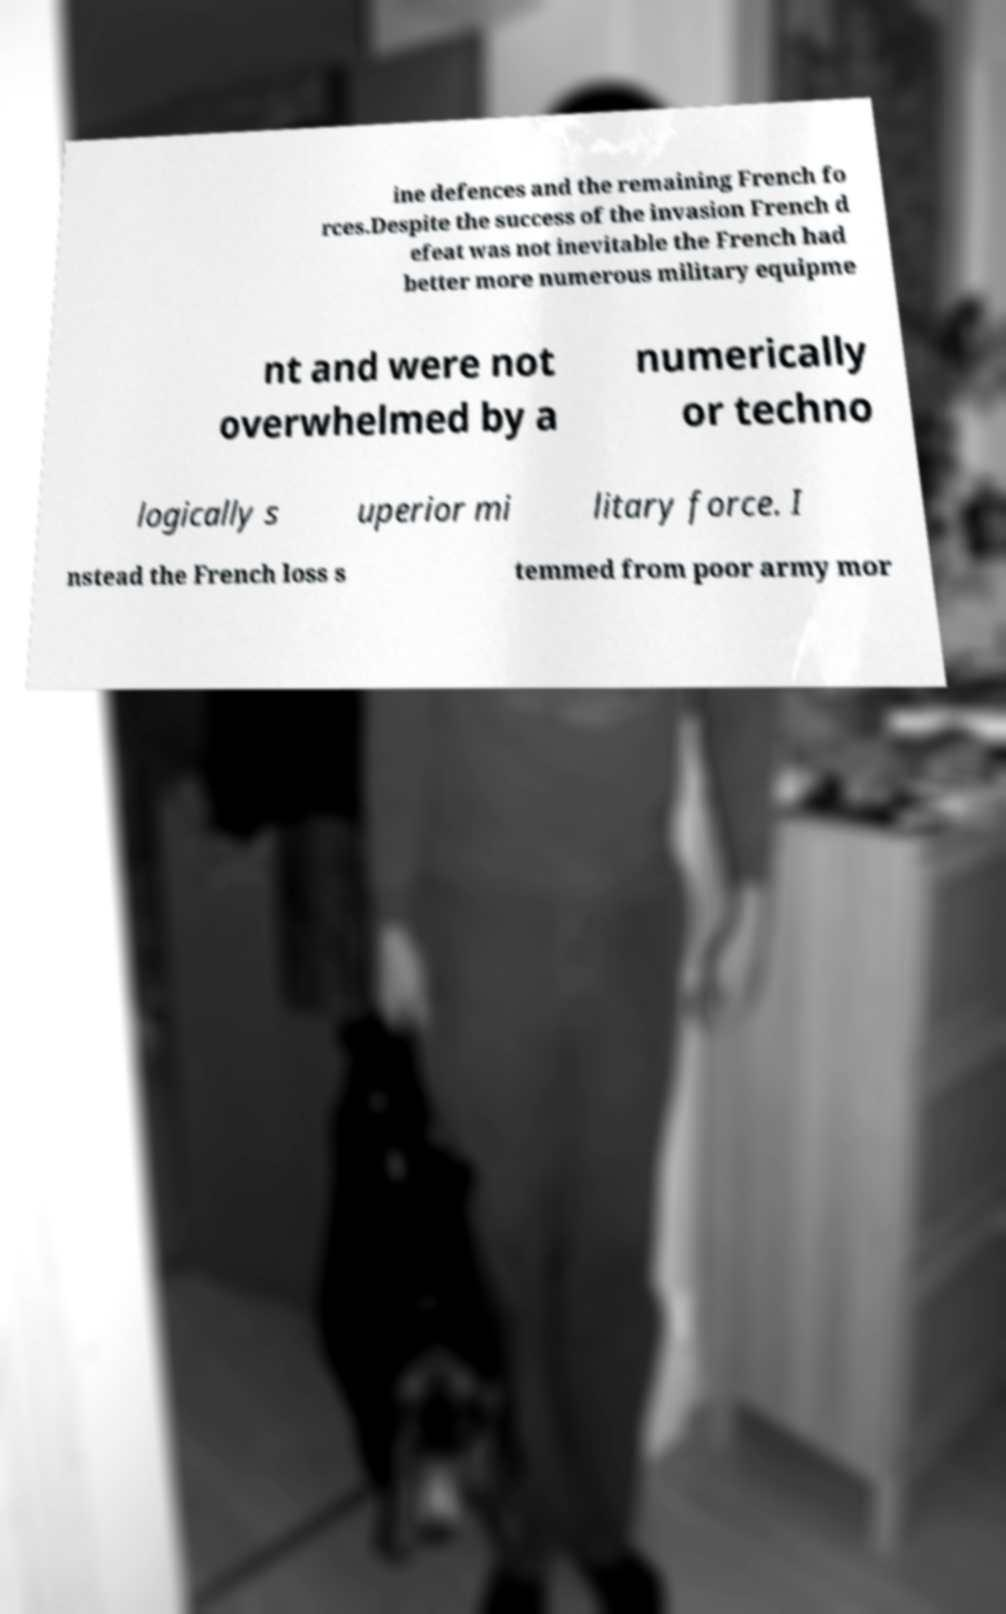Can you read and provide the text displayed in the image?This photo seems to have some interesting text. Can you extract and type it out for me? ine defences and the remaining French fo rces.Despite the success of the invasion French d efeat was not inevitable the French had better more numerous military equipme nt and were not overwhelmed by a numerically or techno logically s uperior mi litary force. I nstead the French loss s temmed from poor army mor 